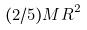Convert formula to latex. <formula><loc_0><loc_0><loc_500><loc_500>( 2 / 5 ) M R ^ { 2 }</formula> 